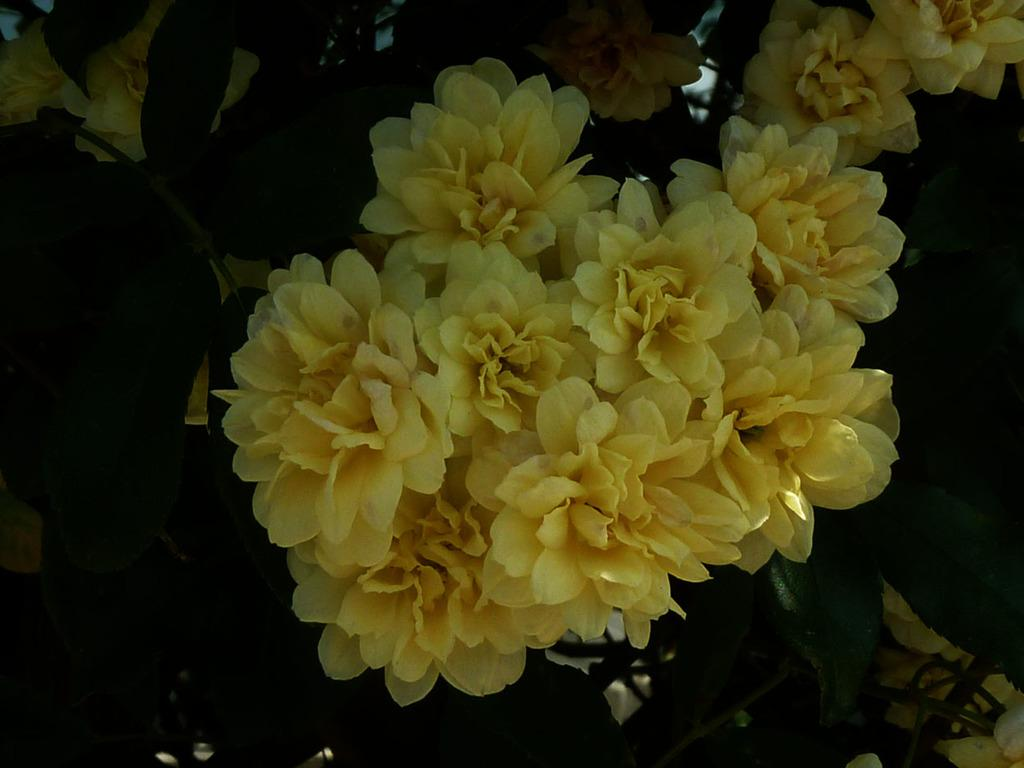What type of plant material can be seen in the image? There are leaves and flowers in the image. Can you describe the flowers in the image? Unfortunately, the facts provided do not give any specific details about the flowers. Are the leaves and flowers part of the same plant or separate plants? The facts provided do not specify whether the leaves and flowers are part of the same plant or separate plants. What type of business is being conducted by the fireman in the image? There is no fireman present in the image, as the facts provided only mention leaves and flowers. How many pails of water are being used by the plants in the image? There is no mention of pails or water in the image, as the facts provided only mention leaves and flowers. 